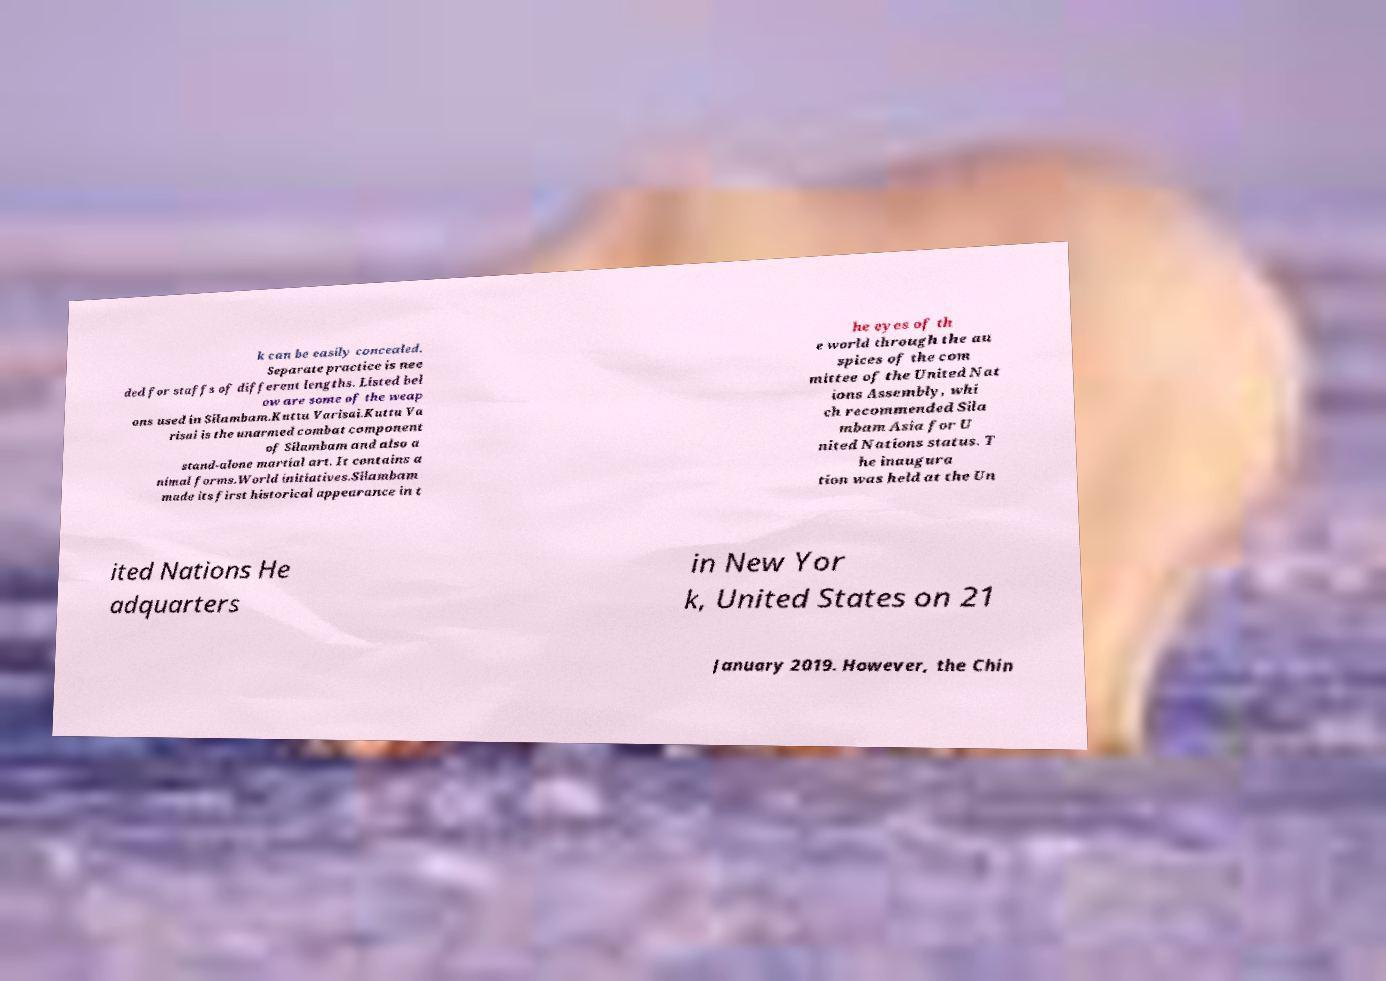For documentation purposes, I need the text within this image transcribed. Could you provide that? k can be easily concealed. Separate practice is nee ded for staffs of different lengths. Listed bel ow are some of the weap ons used in Silambam.Kuttu Varisai.Kuttu Va risai is the unarmed combat component of Silambam and also a stand-alone martial art. It contains a nimal forms.World initiatives.Silambam made its first historical appearance in t he eyes of th e world through the au spices of the com mittee of the United Nat ions Assembly, whi ch recommended Sila mbam Asia for U nited Nations status. T he inaugura tion was held at the Un ited Nations He adquarters in New Yor k, United States on 21 January 2019. However, the Chin 